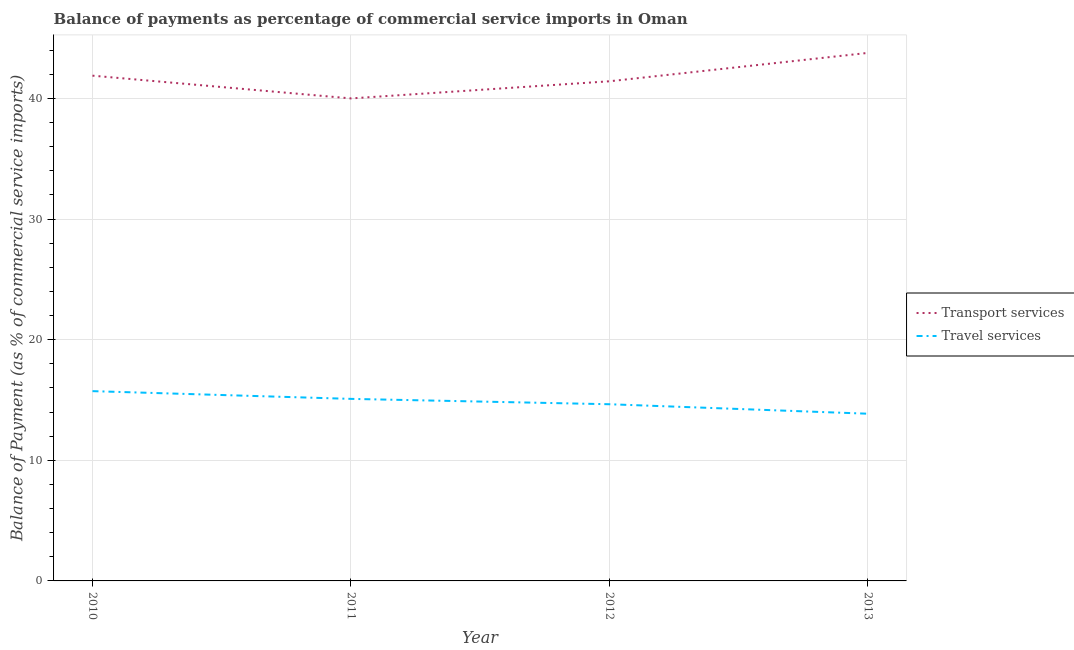Does the line corresponding to balance of payments of transport services intersect with the line corresponding to balance of payments of travel services?
Make the answer very short. No. Is the number of lines equal to the number of legend labels?
Offer a terse response. Yes. What is the balance of payments of transport services in 2010?
Provide a short and direct response. 41.89. Across all years, what is the maximum balance of payments of travel services?
Ensure brevity in your answer.  15.74. Across all years, what is the minimum balance of payments of travel services?
Make the answer very short. 13.86. In which year was the balance of payments of transport services maximum?
Provide a short and direct response. 2013. In which year was the balance of payments of travel services minimum?
Keep it short and to the point. 2013. What is the total balance of payments of travel services in the graph?
Offer a terse response. 59.35. What is the difference between the balance of payments of transport services in 2010 and that in 2012?
Provide a succinct answer. 0.47. What is the difference between the balance of payments of transport services in 2012 and the balance of payments of travel services in 2010?
Provide a short and direct response. 25.69. What is the average balance of payments of travel services per year?
Ensure brevity in your answer.  14.84. In the year 2011, what is the difference between the balance of payments of travel services and balance of payments of transport services?
Offer a very short reply. -24.91. In how many years, is the balance of payments of transport services greater than 32 %?
Offer a terse response. 4. What is the ratio of the balance of payments of transport services in 2010 to that in 2012?
Give a very brief answer. 1.01. What is the difference between the highest and the second highest balance of payments of travel services?
Give a very brief answer. 0.64. What is the difference between the highest and the lowest balance of payments of travel services?
Ensure brevity in your answer.  1.87. In how many years, is the balance of payments of transport services greater than the average balance of payments of transport services taken over all years?
Offer a very short reply. 2. Is the sum of the balance of payments of travel services in 2011 and 2012 greater than the maximum balance of payments of transport services across all years?
Provide a short and direct response. No. Does the balance of payments of transport services monotonically increase over the years?
Ensure brevity in your answer.  No. Is the balance of payments of travel services strictly greater than the balance of payments of transport services over the years?
Your response must be concise. No. Is the balance of payments of travel services strictly less than the balance of payments of transport services over the years?
Offer a very short reply. Yes. How many lines are there?
Provide a succinct answer. 2. What is the difference between two consecutive major ticks on the Y-axis?
Make the answer very short. 10. Are the values on the major ticks of Y-axis written in scientific E-notation?
Your answer should be compact. No. Does the graph contain grids?
Offer a terse response. Yes. Where does the legend appear in the graph?
Offer a very short reply. Center right. How many legend labels are there?
Provide a short and direct response. 2. What is the title of the graph?
Provide a short and direct response. Balance of payments as percentage of commercial service imports in Oman. What is the label or title of the X-axis?
Your answer should be very brief. Year. What is the label or title of the Y-axis?
Make the answer very short. Balance of Payment (as % of commercial service imports). What is the Balance of Payment (as % of commercial service imports) in Transport services in 2010?
Ensure brevity in your answer.  41.89. What is the Balance of Payment (as % of commercial service imports) in Travel services in 2010?
Provide a succinct answer. 15.74. What is the Balance of Payment (as % of commercial service imports) in Transport services in 2011?
Ensure brevity in your answer.  40.01. What is the Balance of Payment (as % of commercial service imports) in Travel services in 2011?
Offer a very short reply. 15.09. What is the Balance of Payment (as % of commercial service imports) of Transport services in 2012?
Keep it short and to the point. 41.43. What is the Balance of Payment (as % of commercial service imports) of Travel services in 2012?
Keep it short and to the point. 14.65. What is the Balance of Payment (as % of commercial service imports) of Transport services in 2013?
Your answer should be compact. 43.78. What is the Balance of Payment (as % of commercial service imports) of Travel services in 2013?
Your answer should be very brief. 13.86. Across all years, what is the maximum Balance of Payment (as % of commercial service imports) of Transport services?
Keep it short and to the point. 43.78. Across all years, what is the maximum Balance of Payment (as % of commercial service imports) in Travel services?
Provide a succinct answer. 15.74. Across all years, what is the minimum Balance of Payment (as % of commercial service imports) of Transport services?
Offer a very short reply. 40.01. Across all years, what is the minimum Balance of Payment (as % of commercial service imports) in Travel services?
Your answer should be very brief. 13.86. What is the total Balance of Payment (as % of commercial service imports) in Transport services in the graph?
Keep it short and to the point. 167.11. What is the total Balance of Payment (as % of commercial service imports) in Travel services in the graph?
Offer a terse response. 59.35. What is the difference between the Balance of Payment (as % of commercial service imports) in Transport services in 2010 and that in 2011?
Provide a short and direct response. 1.89. What is the difference between the Balance of Payment (as % of commercial service imports) of Travel services in 2010 and that in 2011?
Your response must be concise. 0.64. What is the difference between the Balance of Payment (as % of commercial service imports) in Transport services in 2010 and that in 2012?
Offer a very short reply. 0.47. What is the difference between the Balance of Payment (as % of commercial service imports) in Travel services in 2010 and that in 2012?
Your response must be concise. 1.09. What is the difference between the Balance of Payment (as % of commercial service imports) in Transport services in 2010 and that in 2013?
Your answer should be compact. -1.89. What is the difference between the Balance of Payment (as % of commercial service imports) in Travel services in 2010 and that in 2013?
Your response must be concise. 1.87. What is the difference between the Balance of Payment (as % of commercial service imports) of Transport services in 2011 and that in 2012?
Provide a short and direct response. -1.42. What is the difference between the Balance of Payment (as % of commercial service imports) of Travel services in 2011 and that in 2012?
Provide a succinct answer. 0.44. What is the difference between the Balance of Payment (as % of commercial service imports) in Transport services in 2011 and that in 2013?
Provide a succinct answer. -3.77. What is the difference between the Balance of Payment (as % of commercial service imports) in Travel services in 2011 and that in 2013?
Provide a short and direct response. 1.23. What is the difference between the Balance of Payment (as % of commercial service imports) of Transport services in 2012 and that in 2013?
Provide a succinct answer. -2.35. What is the difference between the Balance of Payment (as % of commercial service imports) in Travel services in 2012 and that in 2013?
Ensure brevity in your answer.  0.79. What is the difference between the Balance of Payment (as % of commercial service imports) of Transport services in 2010 and the Balance of Payment (as % of commercial service imports) of Travel services in 2011?
Keep it short and to the point. 26.8. What is the difference between the Balance of Payment (as % of commercial service imports) in Transport services in 2010 and the Balance of Payment (as % of commercial service imports) in Travel services in 2012?
Provide a succinct answer. 27.24. What is the difference between the Balance of Payment (as % of commercial service imports) of Transport services in 2010 and the Balance of Payment (as % of commercial service imports) of Travel services in 2013?
Your response must be concise. 28.03. What is the difference between the Balance of Payment (as % of commercial service imports) in Transport services in 2011 and the Balance of Payment (as % of commercial service imports) in Travel services in 2012?
Offer a terse response. 25.36. What is the difference between the Balance of Payment (as % of commercial service imports) in Transport services in 2011 and the Balance of Payment (as % of commercial service imports) in Travel services in 2013?
Your answer should be very brief. 26.14. What is the difference between the Balance of Payment (as % of commercial service imports) in Transport services in 2012 and the Balance of Payment (as % of commercial service imports) in Travel services in 2013?
Your response must be concise. 27.56. What is the average Balance of Payment (as % of commercial service imports) of Transport services per year?
Provide a short and direct response. 41.78. What is the average Balance of Payment (as % of commercial service imports) of Travel services per year?
Provide a succinct answer. 14.84. In the year 2010, what is the difference between the Balance of Payment (as % of commercial service imports) in Transport services and Balance of Payment (as % of commercial service imports) in Travel services?
Your answer should be compact. 26.16. In the year 2011, what is the difference between the Balance of Payment (as % of commercial service imports) in Transport services and Balance of Payment (as % of commercial service imports) in Travel services?
Offer a very short reply. 24.91. In the year 2012, what is the difference between the Balance of Payment (as % of commercial service imports) in Transport services and Balance of Payment (as % of commercial service imports) in Travel services?
Ensure brevity in your answer.  26.78. In the year 2013, what is the difference between the Balance of Payment (as % of commercial service imports) in Transport services and Balance of Payment (as % of commercial service imports) in Travel services?
Ensure brevity in your answer.  29.92. What is the ratio of the Balance of Payment (as % of commercial service imports) of Transport services in 2010 to that in 2011?
Make the answer very short. 1.05. What is the ratio of the Balance of Payment (as % of commercial service imports) in Travel services in 2010 to that in 2011?
Provide a short and direct response. 1.04. What is the ratio of the Balance of Payment (as % of commercial service imports) in Transport services in 2010 to that in 2012?
Provide a short and direct response. 1.01. What is the ratio of the Balance of Payment (as % of commercial service imports) of Travel services in 2010 to that in 2012?
Provide a short and direct response. 1.07. What is the ratio of the Balance of Payment (as % of commercial service imports) of Transport services in 2010 to that in 2013?
Offer a very short reply. 0.96. What is the ratio of the Balance of Payment (as % of commercial service imports) in Travel services in 2010 to that in 2013?
Provide a succinct answer. 1.14. What is the ratio of the Balance of Payment (as % of commercial service imports) of Transport services in 2011 to that in 2012?
Offer a very short reply. 0.97. What is the ratio of the Balance of Payment (as % of commercial service imports) in Travel services in 2011 to that in 2012?
Offer a terse response. 1.03. What is the ratio of the Balance of Payment (as % of commercial service imports) of Transport services in 2011 to that in 2013?
Provide a short and direct response. 0.91. What is the ratio of the Balance of Payment (as % of commercial service imports) in Travel services in 2011 to that in 2013?
Make the answer very short. 1.09. What is the ratio of the Balance of Payment (as % of commercial service imports) in Transport services in 2012 to that in 2013?
Give a very brief answer. 0.95. What is the ratio of the Balance of Payment (as % of commercial service imports) in Travel services in 2012 to that in 2013?
Keep it short and to the point. 1.06. What is the difference between the highest and the second highest Balance of Payment (as % of commercial service imports) in Transport services?
Provide a short and direct response. 1.89. What is the difference between the highest and the second highest Balance of Payment (as % of commercial service imports) in Travel services?
Your answer should be compact. 0.64. What is the difference between the highest and the lowest Balance of Payment (as % of commercial service imports) of Transport services?
Your answer should be compact. 3.77. What is the difference between the highest and the lowest Balance of Payment (as % of commercial service imports) in Travel services?
Your response must be concise. 1.87. 